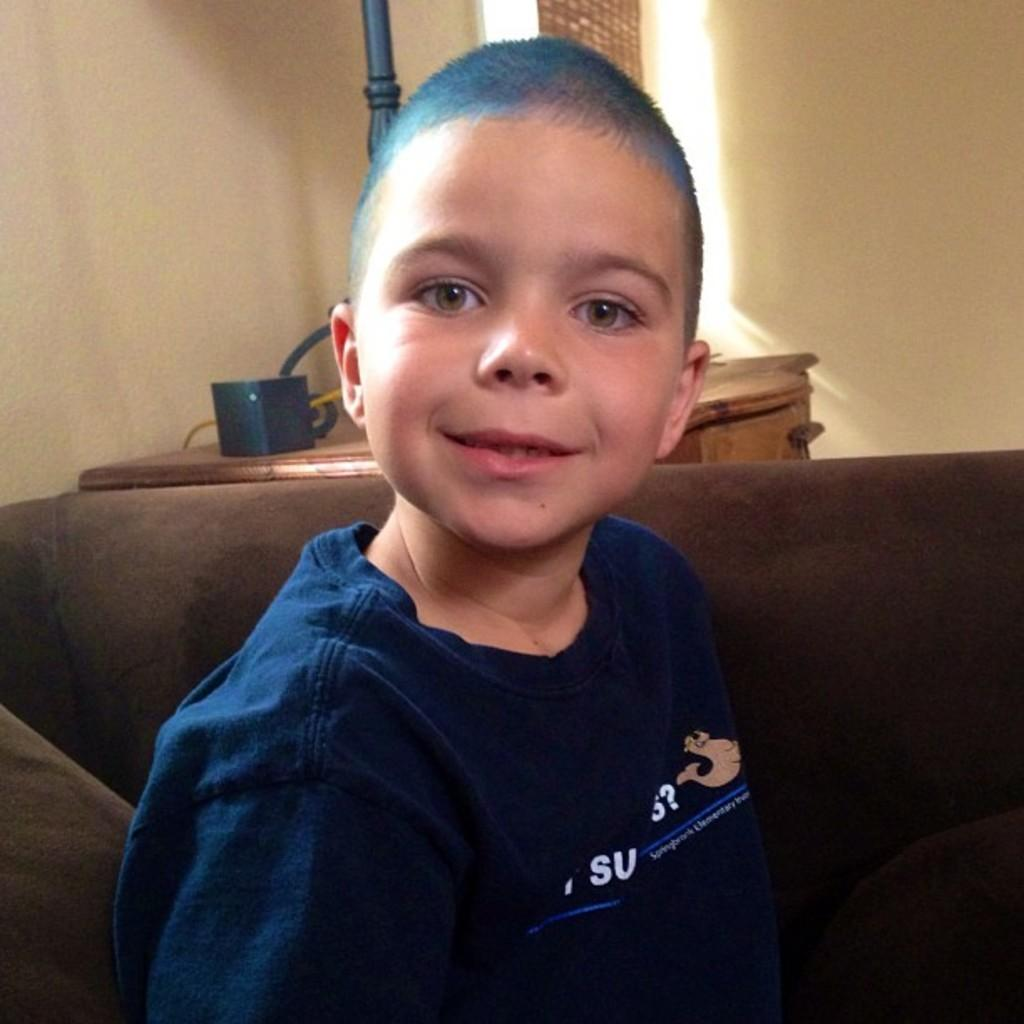What is the boy doing in the image? The boy is sitting on a sofa in the image. What is the boy looking at? The boy is looking at something, but the image does not specify what it is. What can be seen in the background of the image? There is a table and a wall in the background of the image. What color is the chair next to the sofa in the image? There is no chair visible in the image; only a sofa and a table are present in the background. 